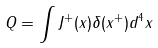Convert formula to latex. <formula><loc_0><loc_0><loc_500><loc_500>Q = \int \nolimits J ^ { + } ( x ) \delta ( x ^ { + } ) d ^ { 4 } x</formula> 